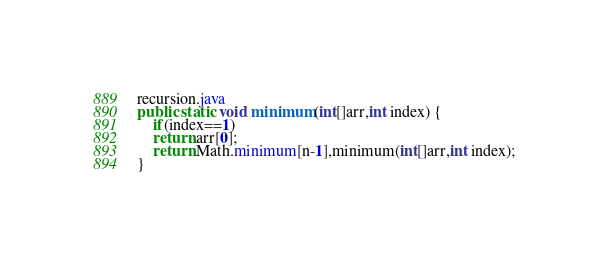Convert code to text. <code><loc_0><loc_0><loc_500><loc_500><_Java_>recursion.java
public static void minimum(int[]arr,int index) {
    if(index==1)
    return arr[0];
    return Math.minimum[n-1],minimum(int[]arr,int index);
}


</code> 